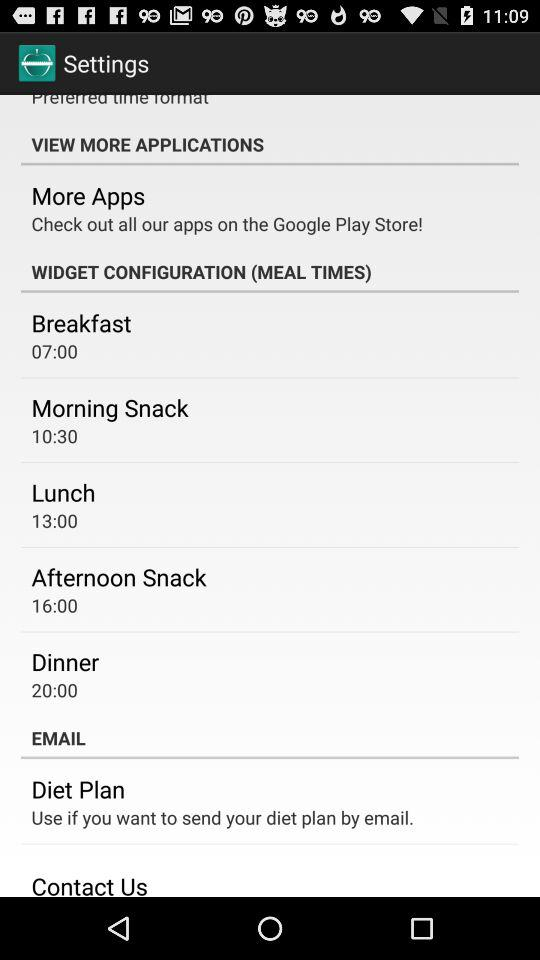What is the breakfast time? Breakfast time is 07:00. 